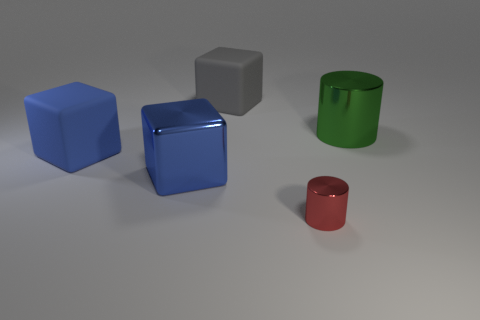Add 2 gray cubes. How many objects exist? 7 Subtract all cubes. How many objects are left? 2 Add 1 large rubber cubes. How many large rubber cubes exist? 3 Subtract 0 yellow balls. How many objects are left? 5 Subtract all large green metal objects. Subtract all big gray matte cubes. How many objects are left? 3 Add 4 blue shiny objects. How many blue shiny objects are left? 5 